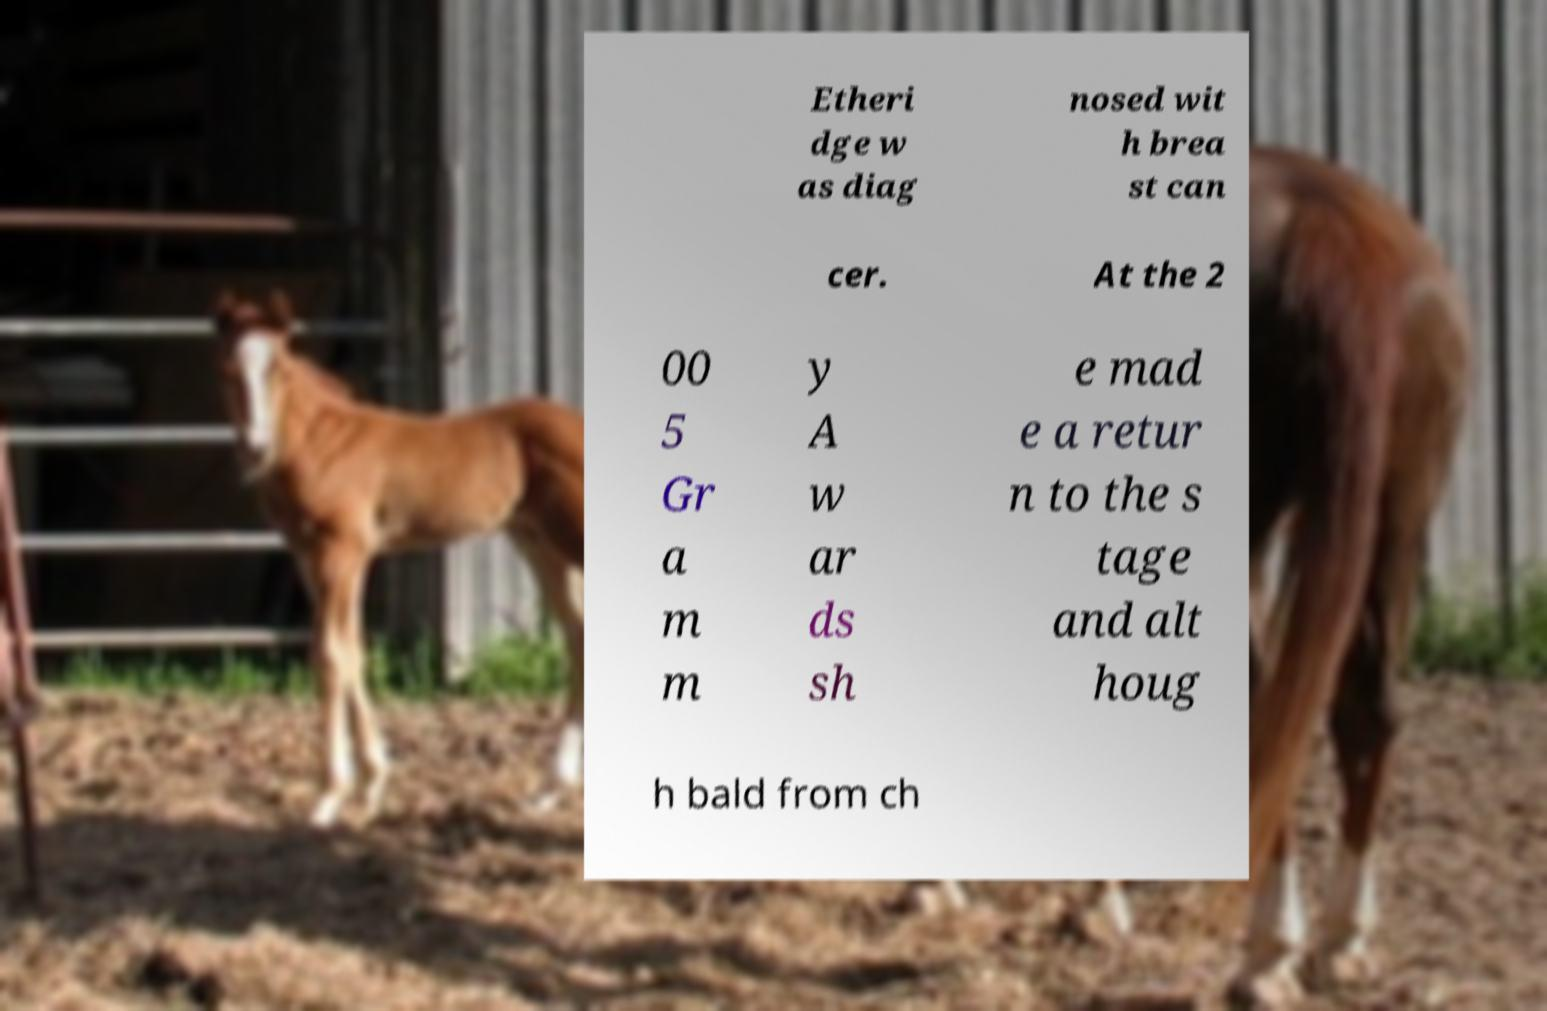Could you assist in decoding the text presented in this image and type it out clearly? Etheri dge w as diag nosed wit h brea st can cer. At the 2 00 5 Gr a m m y A w ar ds sh e mad e a retur n to the s tage and alt houg h bald from ch 